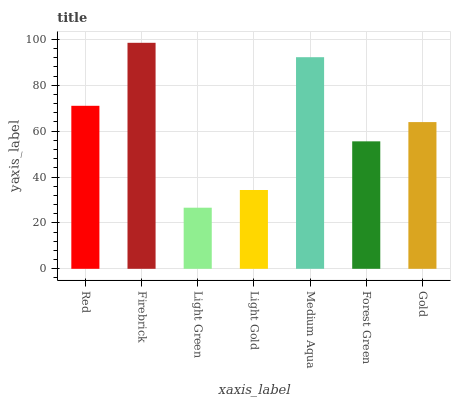Is Light Green the minimum?
Answer yes or no. Yes. Is Firebrick the maximum?
Answer yes or no. Yes. Is Firebrick the minimum?
Answer yes or no. No. Is Light Green the maximum?
Answer yes or no. No. Is Firebrick greater than Light Green?
Answer yes or no. Yes. Is Light Green less than Firebrick?
Answer yes or no. Yes. Is Light Green greater than Firebrick?
Answer yes or no. No. Is Firebrick less than Light Green?
Answer yes or no. No. Is Gold the high median?
Answer yes or no. Yes. Is Gold the low median?
Answer yes or no. Yes. Is Light Green the high median?
Answer yes or no. No. Is Light Gold the low median?
Answer yes or no. No. 